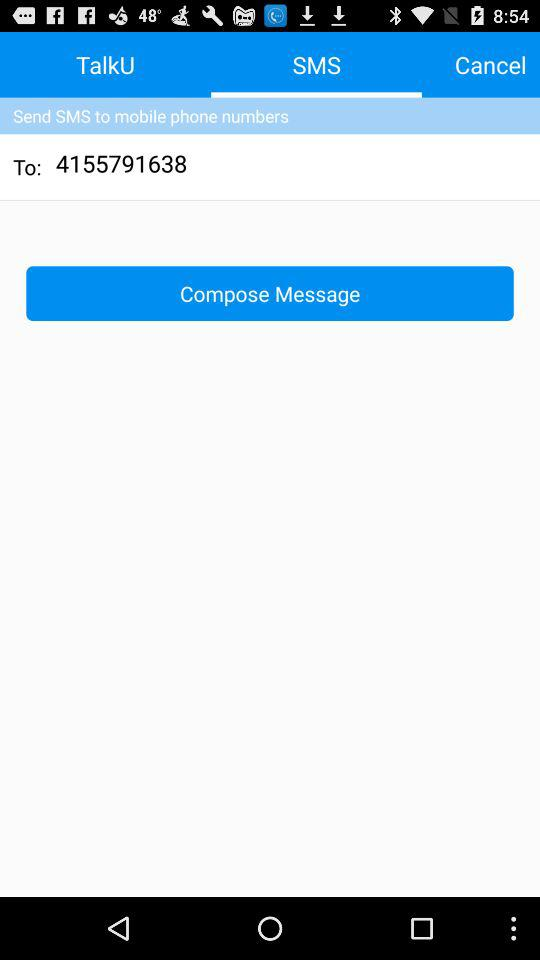What number is the message to be sent to? The number is 4155791638. 